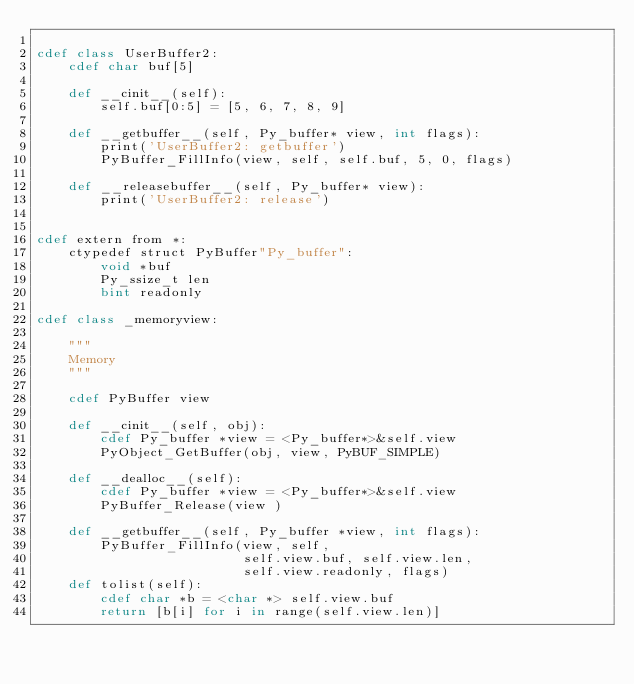Convert code to text. <code><loc_0><loc_0><loc_500><loc_500><_Cython_>
cdef class UserBuffer2:
    cdef char buf[5]

    def __cinit__(self):
        self.buf[0:5] = [5, 6, 7, 8, 9]

    def __getbuffer__(self, Py_buffer* view, int flags):
        print('UserBuffer2: getbuffer')
        PyBuffer_FillInfo(view, self, self.buf, 5, 0, flags)

    def __releasebuffer__(self, Py_buffer* view):
        print('UserBuffer2: release')


cdef extern from *:
    ctypedef struct PyBuffer"Py_buffer":
        void *buf
        Py_ssize_t len
        bint readonly

cdef class _memoryview:

    """
    Memory
    """

    cdef PyBuffer view

    def __cinit__(self, obj):
        cdef Py_buffer *view = <Py_buffer*>&self.view
        PyObject_GetBuffer(obj, view, PyBUF_SIMPLE)

    def __dealloc__(self):
        cdef Py_buffer *view = <Py_buffer*>&self.view
        PyBuffer_Release(view )
        
    def __getbuffer__(self, Py_buffer *view, int flags):
        PyBuffer_FillInfo(view, self,
                          self.view.buf, self.view.len,
                          self.view.readonly, flags)
    def tolist(self):
        cdef char *b = <char *> self.view.buf
        return [b[i] for i in range(self.view.len)]
</code> 